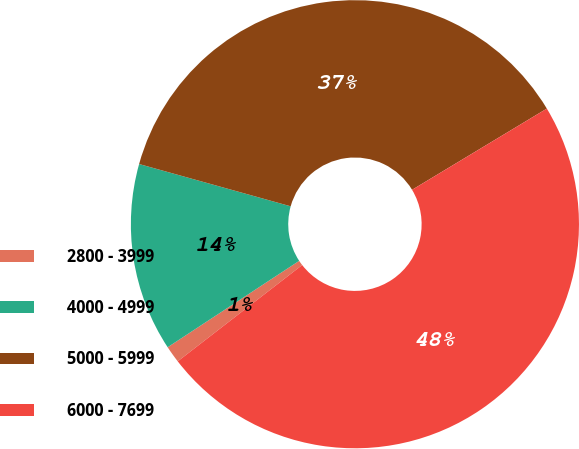Convert chart to OTSL. <chart><loc_0><loc_0><loc_500><loc_500><pie_chart><fcel>2800 - 3999<fcel>4000 - 4999<fcel>5000 - 5999<fcel>6000 - 7699<nl><fcel>1.23%<fcel>13.58%<fcel>37.04%<fcel>48.15%<nl></chart> 